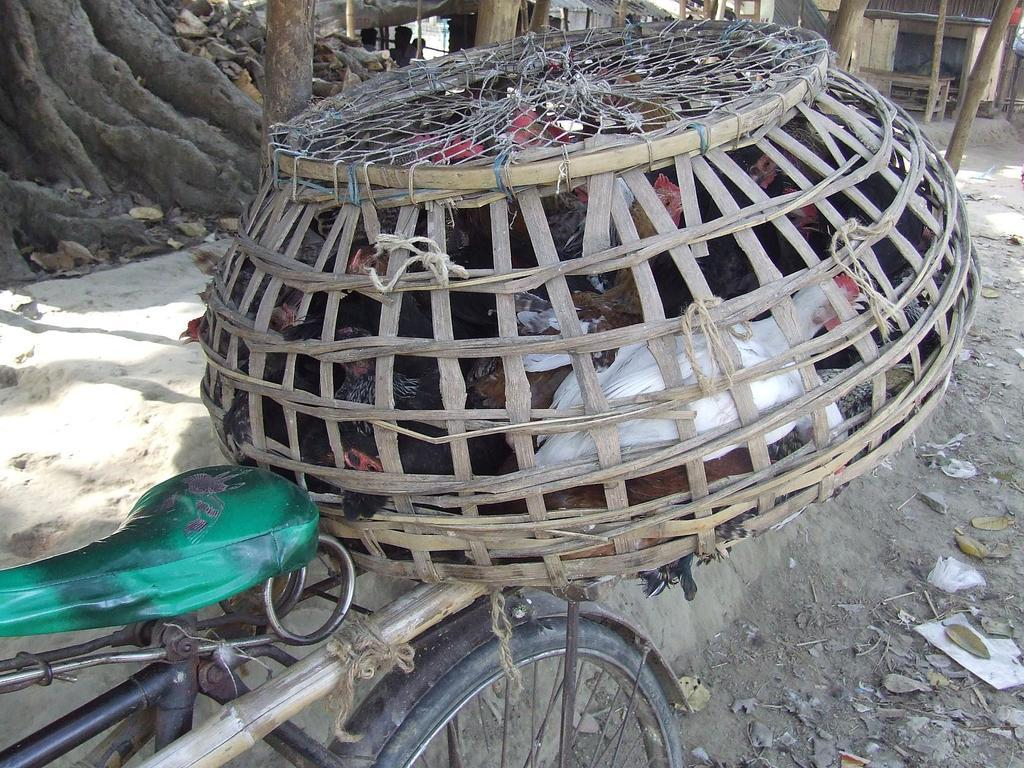What animals are in the center of the image? There are hens in the center of the image. What is covering the hens in the image? The hens are under a basket. What can be seen in the background of the image? There is a tree and a house in the background of the image. What object is at the bottom of the image? There is a cycle at the bottom of the image. What type of gun is being used by the geese in the image? There are no geese or guns present in the image; it features hens under a basket. What type of brass instrument can be seen in the image? There is no brass instrument present in the image. 